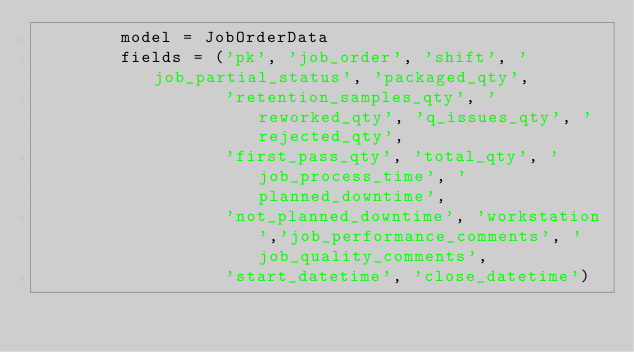Convert code to text. <code><loc_0><loc_0><loc_500><loc_500><_Python_>        model = JobOrderData
        fields = ('pk', 'job_order', 'shift', 'job_partial_status', 'packaged_qty',
                  'retention_samples_qty', 'reworked_qty', 'q_issues_qty', 'rejected_qty',
                  'first_pass_qty', 'total_qty', 'job_process_time', 'planned_downtime',
                  'not_planned_downtime', 'workstation','job_performance_comments', 'job_quality_comments',
                  'start_datetime', 'close_datetime')

        </code> 